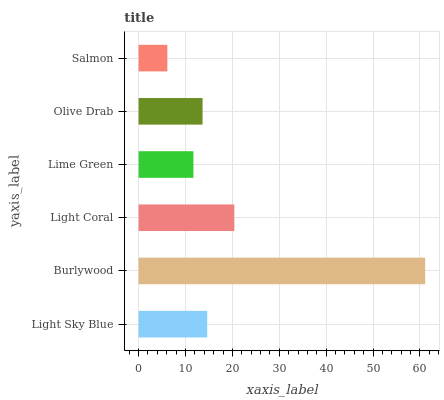Is Salmon the minimum?
Answer yes or no. Yes. Is Burlywood the maximum?
Answer yes or no. Yes. Is Light Coral the minimum?
Answer yes or no. No. Is Light Coral the maximum?
Answer yes or no. No. Is Burlywood greater than Light Coral?
Answer yes or no. Yes. Is Light Coral less than Burlywood?
Answer yes or no. Yes. Is Light Coral greater than Burlywood?
Answer yes or no. No. Is Burlywood less than Light Coral?
Answer yes or no. No. Is Light Sky Blue the high median?
Answer yes or no. Yes. Is Olive Drab the low median?
Answer yes or no. Yes. Is Light Coral the high median?
Answer yes or no. No. Is Lime Green the low median?
Answer yes or no. No. 